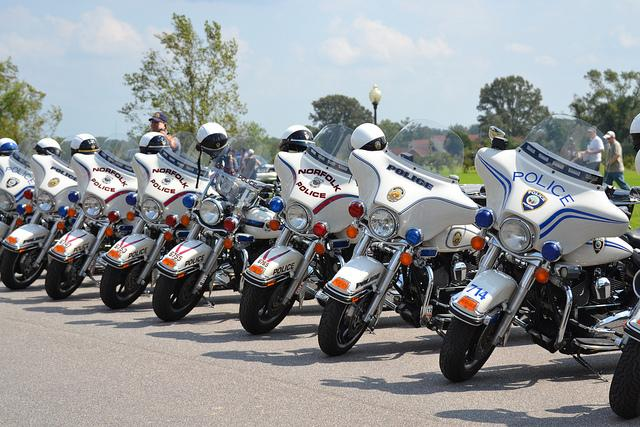What is beneath the number 714?

Choices:
A) slug
B) tire
C) grass
D) paw tire 